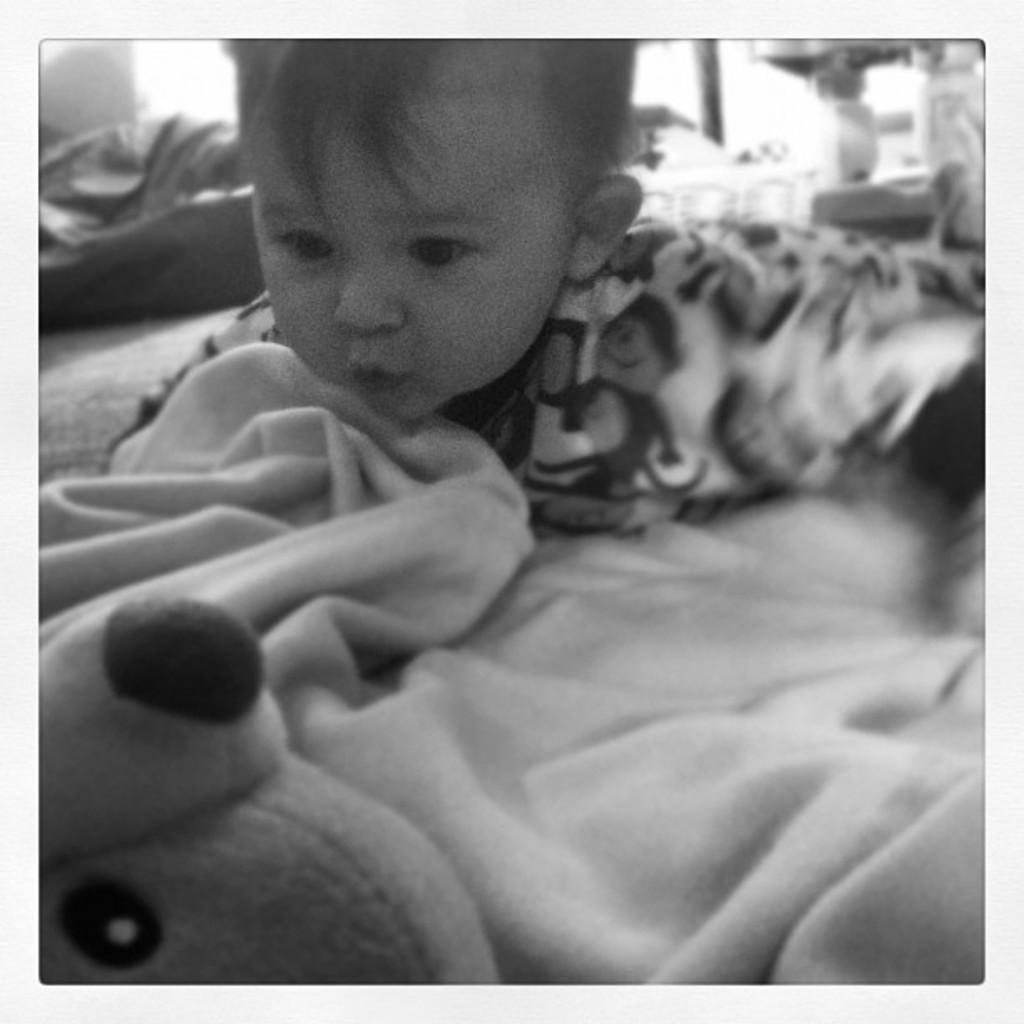What is the color scheme of the image? The image is black and white. What is the main subject in the center of the image? There is a baby lying on the floor in the center of the image. What type of material is visible in the image? There is cloth visible in the image. What other object can be seen in the image? There is a doll in the image. What is located at the top of the image? There are objects visible at the top of the image. What is the background of the image? There is a wall in the image. How does the baby attempt to untie the knot in the image? There is no knot present in the image; it is a black and white image with a baby lying on the floor, cloth, a doll, and objects at the top. What type of bike is visible in the image? There is no bike present in the image; it is a black and white image with a baby lying on the floor, cloth, a doll, and objects at the top. 